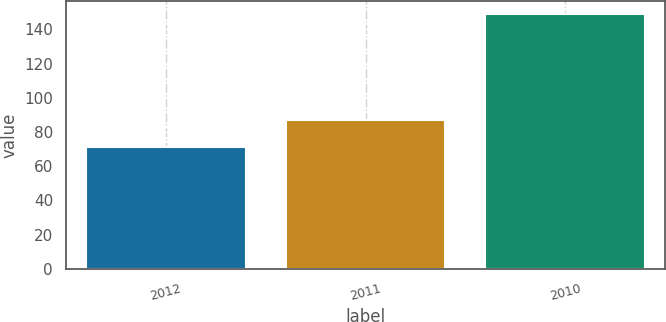Convert chart to OTSL. <chart><loc_0><loc_0><loc_500><loc_500><bar_chart><fcel>2012<fcel>2011<fcel>2010<nl><fcel>71<fcel>87<fcel>149<nl></chart> 